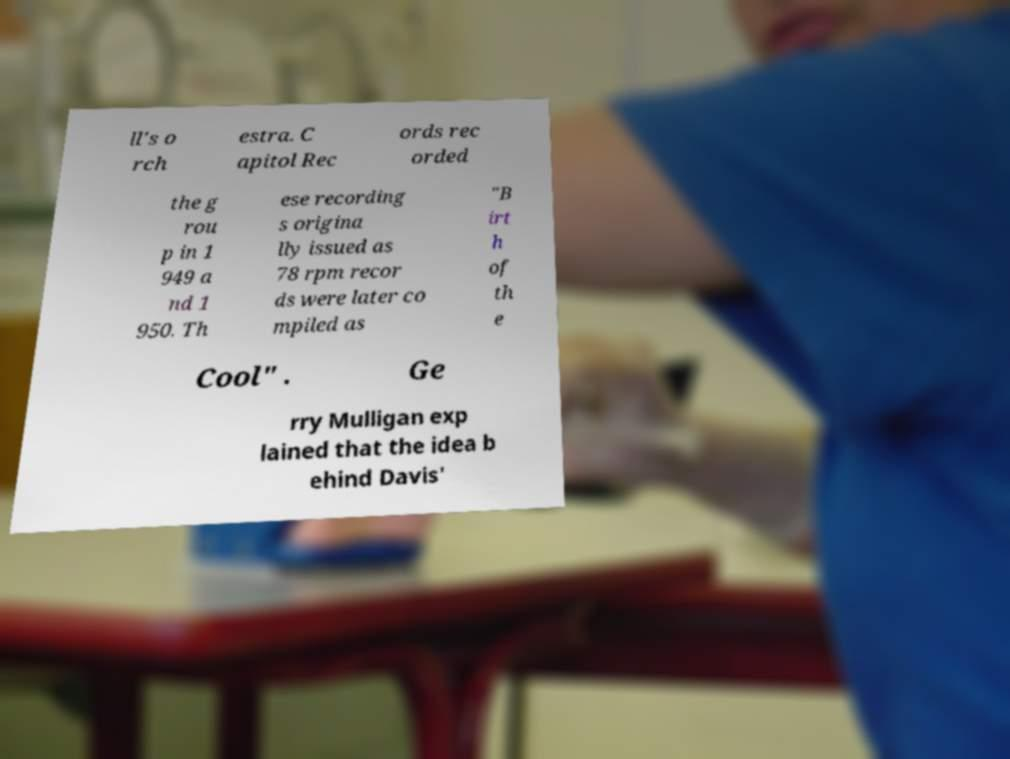What messages or text are displayed in this image? I need them in a readable, typed format. ll's o rch estra. C apitol Rec ords rec orded the g rou p in 1 949 a nd 1 950. Th ese recording s origina lly issued as 78 rpm recor ds were later co mpiled as "B irt h of th e Cool" . Ge rry Mulligan exp lained that the idea b ehind Davis' 